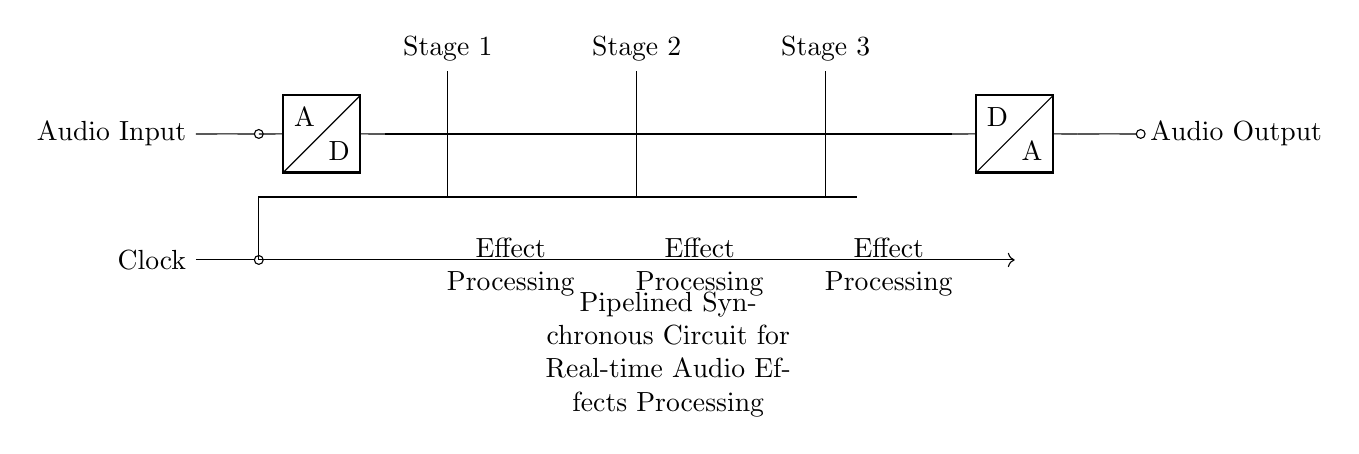What is the input component in this circuit? The input component is an ADC, which converts the analog audio input into a digital signal for further processing.
Answer: ADC What is the output component in this circuit? The output component is a DAC, which converts the processed digital signal back into an analog audio output.
Answer: DAC How many pipeline stages are present in this circuit? There are three pipeline stages, each represented by a flip-flop D that processes the incoming data sequentially.
Answer: Three What is the purpose of the clock signal in this circuit? The clock signal synchronizes the data transfer through the flip-flops, ensuring that data is processed in a timely, orderly manner.
Answer: Synchronization What type of circuit is this? This is a synchronous circuit, as it is driven by a clock signal to coordinate the operations of the different components in the flow of data.
Answer: Synchronous How do the pipeline stages relate to audio effect processing? Each pipeline stage represents a distinct step in the effect processing chain, allowing for successive treatments of the audio signal, enhancing performance and reducing latency.
Answer: Successive steps 